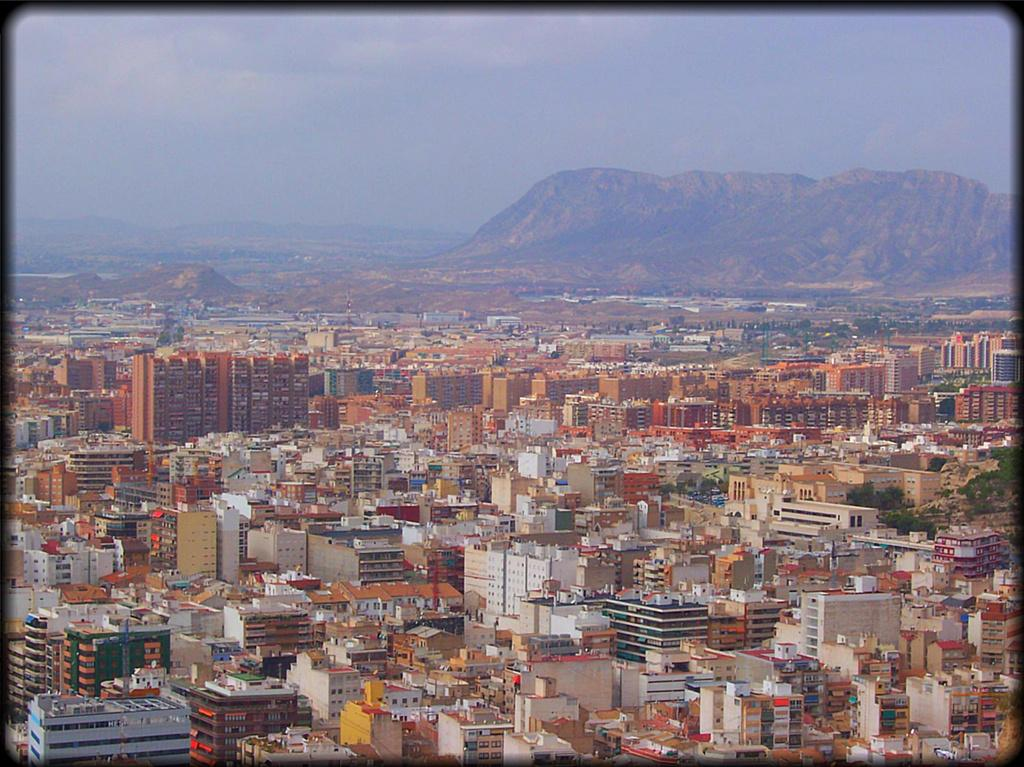What type of image is being described? The image is a photo. What structures can be seen in the image? There are buildings in the image. What type of vegetation is present in the image? There are trees in the image. What natural features are visible in the background of the image? There are mountains visible in the background of the image. What is visible at the top of the image? The sky is visible at the top of the image. How many sisters are sitting on the furniture in the image? There are no sisters or furniture present in the image. 